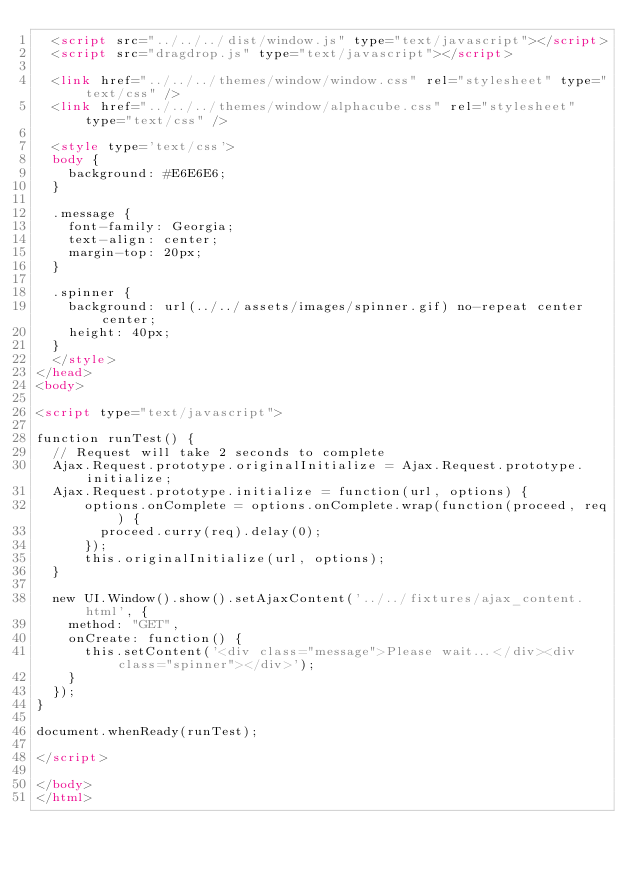<code> <loc_0><loc_0><loc_500><loc_500><_HTML_>  <script src="../../../dist/window.js" type="text/javascript"></script>
  <script src="dragdrop.js" type="text/javascript"></script>

  <link href="../../../themes/window/window.css" rel="stylesheet" type="text/css" />
  <link href="../../../themes/window/alphacube.css" rel="stylesheet" type="text/css" />

  <style type='text/css'>
  body {
    background: #E6E6E6;
  }
    
  .message {
    font-family: Georgia;
    text-align: center;
    margin-top: 20px;
  }
  
  .spinner {
    background: url(../../assets/images/spinner.gif) no-repeat center center;
    height: 40px;
  }
  </style>
</head>
<body>

<script type="text/javascript">

function runTest() {
  // Request will take 2 seconds to complete
  Ajax.Request.prototype.originalInitialize = Ajax.Request.prototype.initialize;
  Ajax.Request.prototype.initialize = function(url, options) {
      options.onComplete = options.onComplete.wrap(function(proceed, req) {
        proceed.curry(req).delay(0);
      });
      this.originalInitialize(url, options);
  }

  new UI.Window().show().setAjaxContent('../../fixtures/ajax_content.html', {
    method: "GET", 
    onCreate: function() {   
      this.setContent('<div class="message">Please wait...</div><div class="spinner"></div>');   
    }
  });                 
}

document.whenReady(runTest);

</script>

</body>
</html>
</code> 